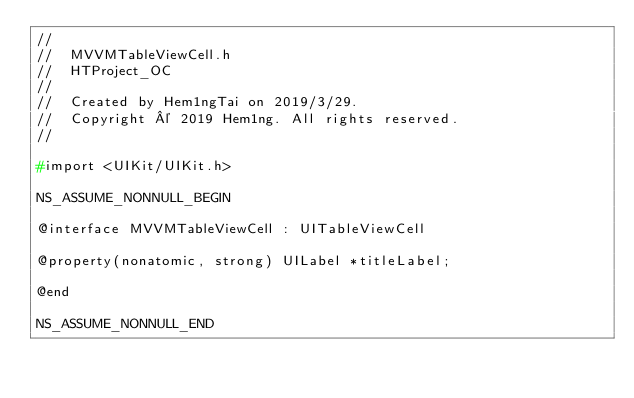Convert code to text. <code><loc_0><loc_0><loc_500><loc_500><_C_>//
//  MVVMTableViewCell.h
//  HTProject_OC
//
//  Created by Hem1ngTai on 2019/3/29.
//  Copyright © 2019 Hem1ng. All rights reserved.
//

#import <UIKit/UIKit.h>

NS_ASSUME_NONNULL_BEGIN

@interface MVVMTableViewCell : UITableViewCell

@property(nonatomic, strong) UILabel *titleLabel;

@end

NS_ASSUME_NONNULL_END
</code> 